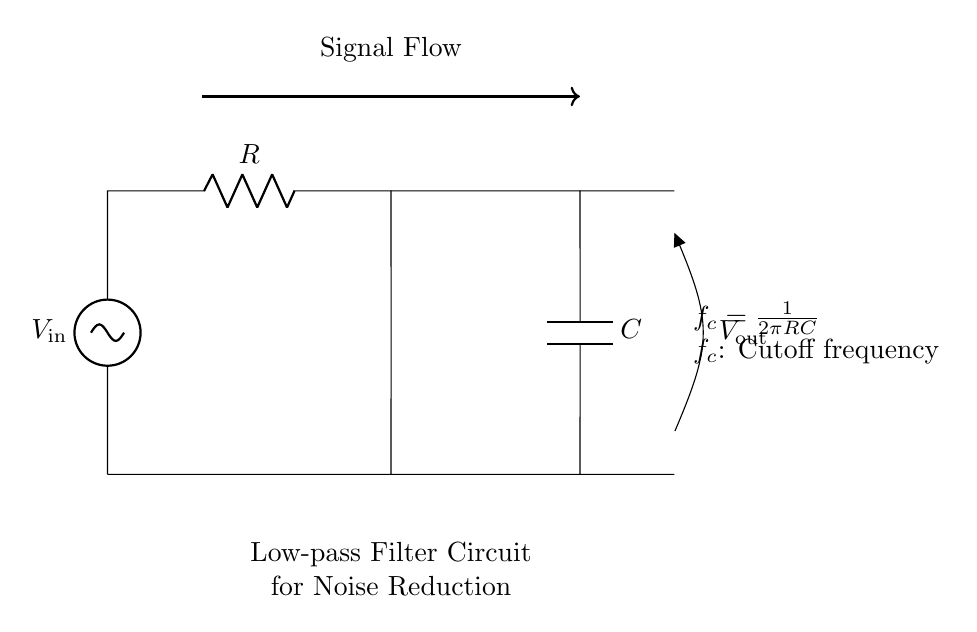What components are present in this circuit? The diagram clearly shows a resistor and a capacitor connected in series, which are the primary components in this low-pass filter circuit.
Answer: Resistor and Capacitor What is the purpose of this circuit? The circuit is designed as a low-pass filter, which allows low frequencies to pass through while attenuating higher frequencies, making it useful for noise reduction in communication systems.
Answer: Noise reduction What is the cutoff frequency formula used in this circuit? The diagram includes the formula for cutoff frequency, which is expressed as f_c = 1/(2πRC); this shows the relationship between the cutoff frequency, resistance, and capacitance.
Answer: f_c = 1/(2πRC) How would increasing the resistance affect the cutoff frequency? According to the cutoff frequency formula, increasing the resistance (R) will decrease the cutoff frequency (f_c), meaning it will allow even lower frequencies to pass through.
Answer: Decrease If the input voltage is 10 volts, what is the maximum output voltage theoretically? In a low-pass filter, the maximum output voltage is equal to the input voltage at the cutoff frequency and below; since it's a passive filter without gain, the maximum output voltage is the same as the input voltage.
Answer: 10 volts What happens to high-frequency signals in this circuit? High-frequency signals are attenuated (reduced in amplitude) by the circuit; they do not pass through effectively, thereby achieving noise reduction in communication systems.
Answer: Attenuated What is the signal flow direction in this circuit? The signal flows from the input voltage source (V_in) through the resistor (R) and capacitor (C) until it reaches the output (V_out); this is indicated by the arrows in the diagram.
Answer: Left to right 